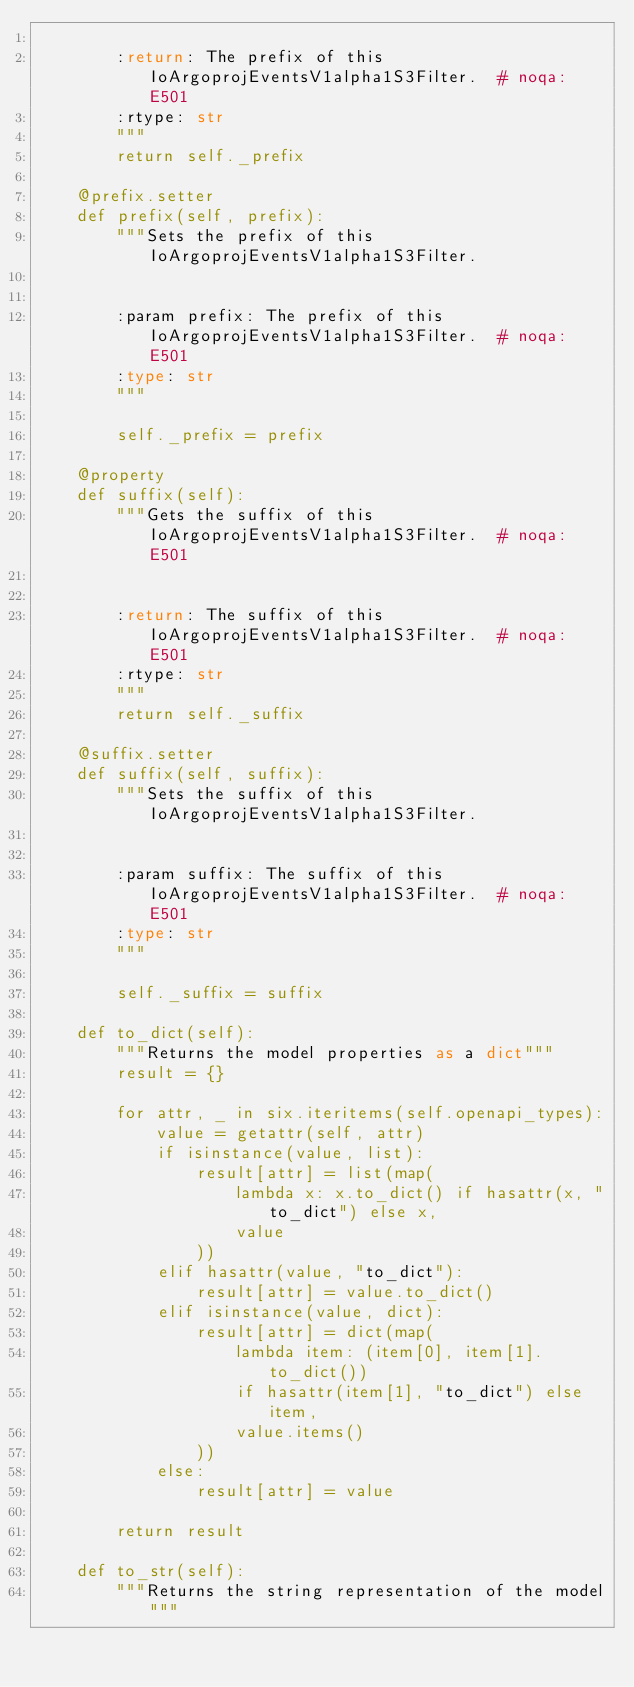<code> <loc_0><loc_0><loc_500><loc_500><_Python_>
        :return: The prefix of this IoArgoprojEventsV1alpha1S3Filter.  # noqa: E501
        :rtype: str
        """
        return self._prefix

    @prefix.setter
    def prefix(self, prefix):
        """Sets the prefix of this IoArgoprojEventsV1alpha1S3Filter.


        :param prefix: The prefix of this IoArgoprojEventsV1alpha1S3Filter.  # noqa: E501
        :type: str
        """

        self._prefix = prefix

    @property
    def suffix(self):
        """Gets the suffix of this IoArgoprojEventsV1alpha1S3Filter.  # noqa: E501


        :return: The suffix of this IoArgoprojEventsV1alpha1S3Filter.  # noqa: E501
        :rtype: str
        """
        return self._suffix

    @suffix.setter
    def suffix(self, suffix):
        """Sets the suffix of this IoArgoprojEventsV1alpha1S3Filter.


        :param suffix: The suffix of this IoArgoprojEventsV1alpha1S3Filter.  # noqa: E501
        :type: str
        """

        self._suffix = suffix

    def to_dict(self):
        """Returns the model properties as a dict"""
        result = {}

        for attr, _ in six.iteritems(self.openapi_types):
            value = getattr(self, attr)
            if isinstance(value, list):
                result[attr] = list(map(
                    lambda x: x.to_dict() if hasattr(x, "to_dict") else x,
                    value
                ))
            elif hasattr(value, "to_dict"):
                result[attr] = value.to_dict()
            elif isinstance(value, dict):
                result[attr] = dict(map(
                    lambda item: (item[0], item[1].to_dict())
                    if hasattr(item[1], "to_dict") else item,
                    value.items()
                ))
            else:
                result[attr] = value

        return result

    def to_str(self):
        """Returns the string representation of the model"""</code> 